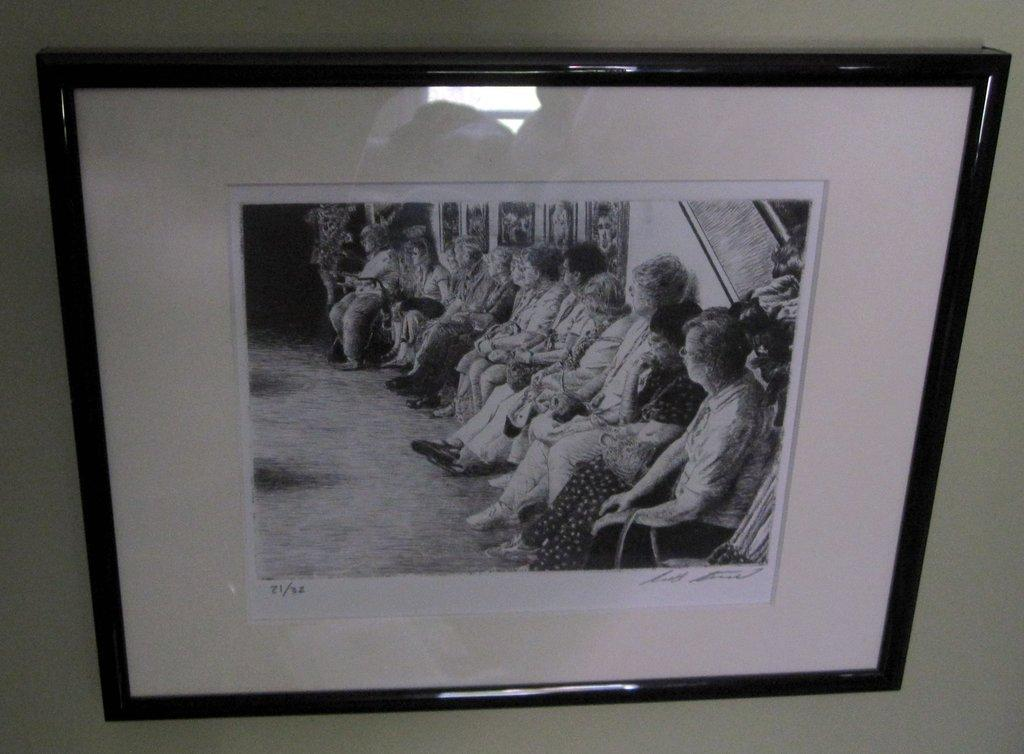Provide a one-sentence caption for the provided image. a photo that has the number 21 on it. 